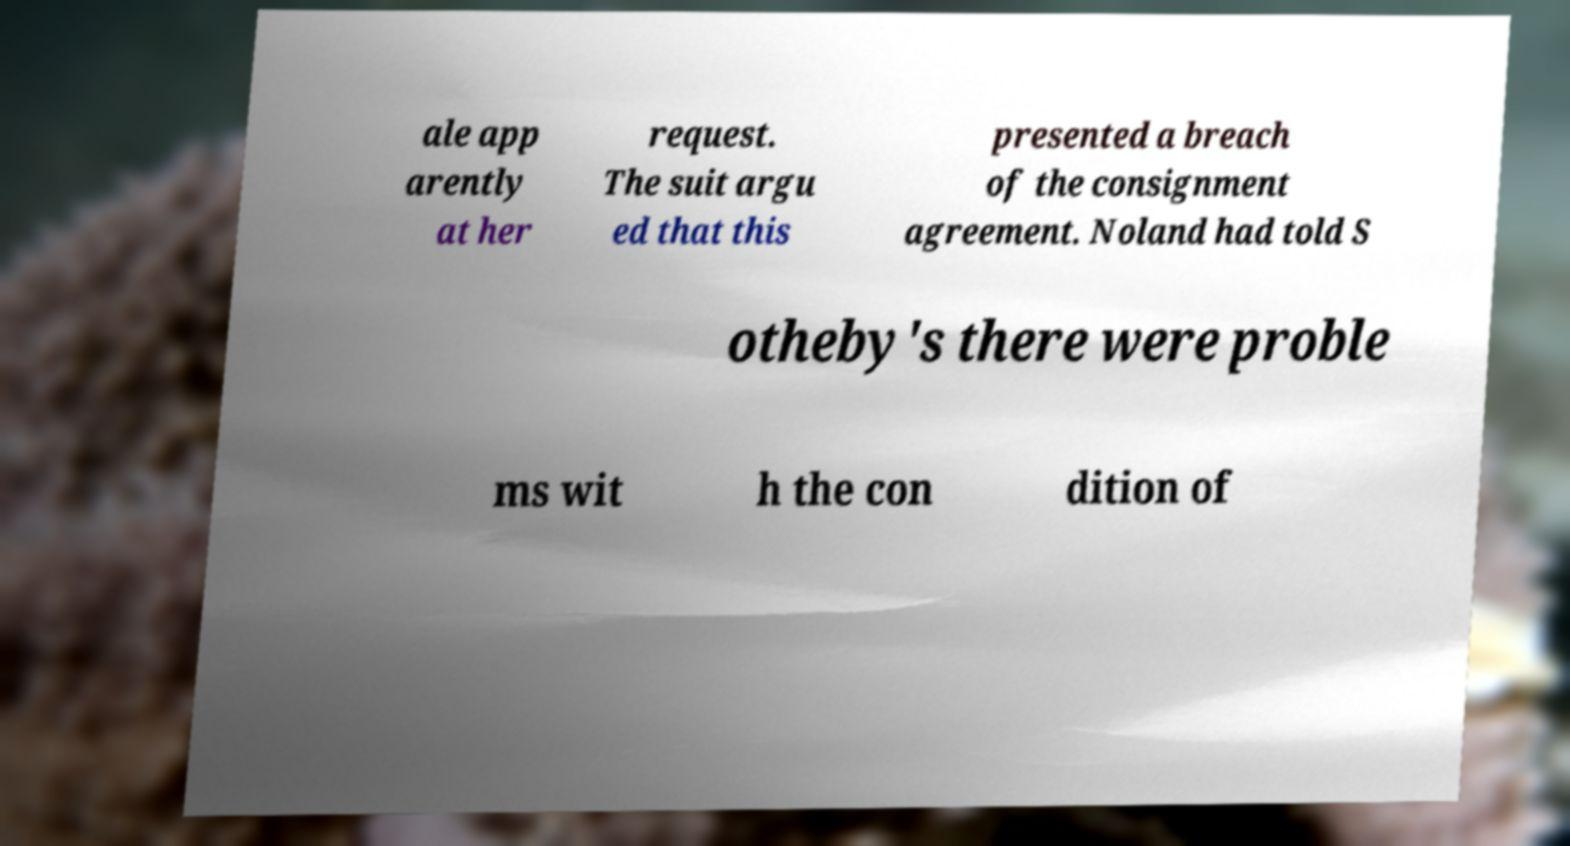Please identify and transcribe the text found in this image. ale app arently at her request. The suit argu ed that this presented a breach of the consignment agreement. Noland had told S otheby's there were proble ms wit h the con dition of 